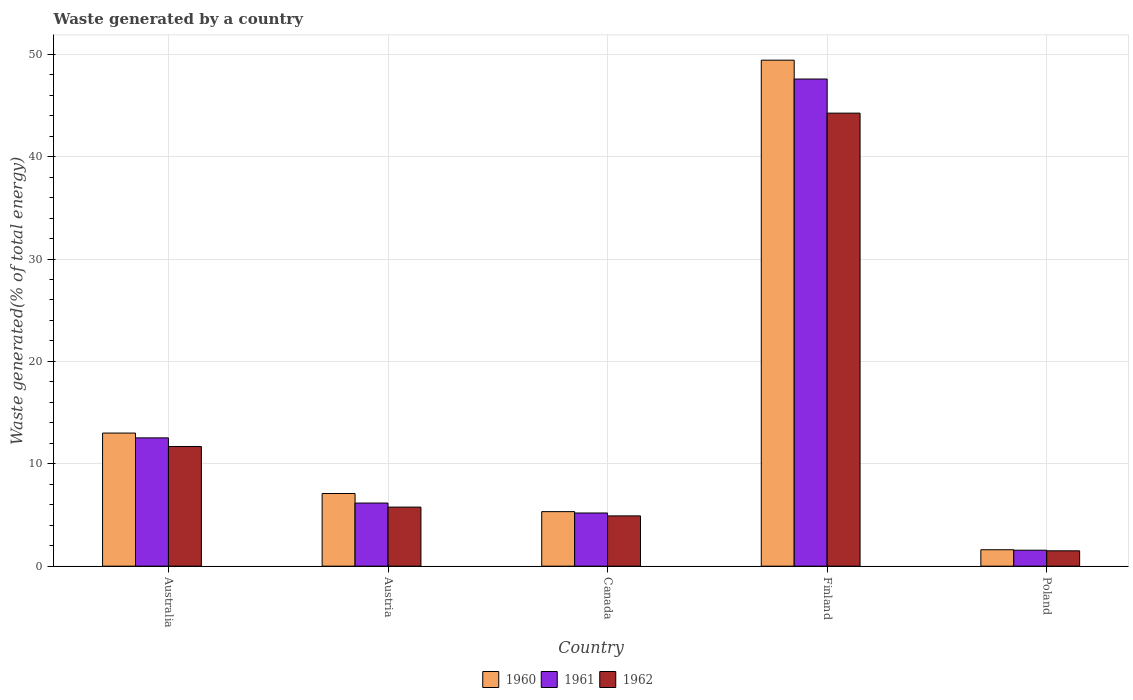How many different coloured bars are there?
Your answer should be very brief. 3. How many groups of bars are there?
Offer a terse response. 5. How many bars are there on the 1st tick from the left?
Your answer should be very brief. 3. In how many cases, is the number of bars for a given country not equal to the number of legend labels?
Offer a terse response. 0. What is the total waste generated in 1962 in Australia?
Give a very brief answer. 11.69. Across all countries, what is the maximum total waste generated in 1960?
Ensure brevity in your answer.  49.42. Across all countries, what is the minimum total waste generated in 1961?
Provide a succinct answer. 1.56. What is the total total waste generated in 1960 in the graph?
Offer a very short reply. 76.45. What is the difference between the total waste generated in 1960 in Canada and that in Poland?
Your response must be concise. 3.72. What is the difference between the total waste generated in 1961 in Australia and the total waste generated in 1960 in Finland?
Your answer should be very brief. -36.89. What is the average total waste generated in 1960 per country?
Offer a terse response. 15.29. What is the difference between the total waste generated of/in 1962 and total waste generated of/in 1960 in Canada?
Offer a terse response. -0.42. In how many countries, is the total waste generated in 1962 greater than 38 %?
Give a very brief answer. 1. What is the ratio of the total waste generated in 1960 in Australia to that in Canada?
Keep it short and to the point. 2.44. What is the difference between the highest and the second highest total waste generated in 1960?
Offer a very short reply. 36.42. What is the difference between the highest and the lowest total waste generated in 1962?
Provide a short and direct response. 42.75. In how many countries, is the total waste generated in 1962 greater than the average total waste generated in 1962 taken over all countries?
Provide a short and direct response. 1. What does the 3rd bar from the left in Australia represents?
Your answer should be compact. 1962. Is it the case that in every country, the sum of the total waste generated in 1962 and total waste generated in 1961 is greater than the total waste generated in 1960?
Keep it short and to the point. Yes. How many bars are there?
Offer a terse response. 15. What is the difference between two consecutive major ticks on the Y-axis?
Make the answer very short. 10. Does the graph contain any zero values?
Provide a succinct answer. No. Does the graph contain grids?
Ensure brevity in your answer.  Yes. Where does the legend appear in the graph?
Offer a very short reply. Bottom center. What is the title of the graph?
Your response must be concise. Waste generated by a country. What is the label or title of the X-axis?
Provide a succinct answer. Country. What is the label or title of the Y-axis?
Provide a short and direct response. Waste generated(% of total energy). What is the Waste generated(% of total energy) of 1960 in Australia?
Make the answer very short. 13. What is the Waste generated(% of total energy) of 1961 in Australia?
Your answer should be compact. 12.53. What is the Waste generated(% of total energy) in 1962 in Australia?
Offer a very short reply. 11.69. What is the Waste generated(% of total energy) of 1960 in Austria?
Give a very brief answer. 7.1. What is the Waste generated(% of total energy) of 1961 in Austria?
Keep it short and to the point. 6.16. What is the Waste generated(% of total energy) of 1962 in Austria?
Ensure brevity in your answer.  5.77. What is the Waste generated(% of total energy) in 1960 in Canada?
Provide a short and direct response. 5.33. What is the Waste generated(% of total energy) in 1961 in Canada?
Provide a succinct answer. 5.19. What is the Waste generated(% of total energy) in 1962 in Canada?
Provide a succinct answer. 4.91. What is the Waste generated(% of total energy) of 1960 in Finland?
Offer a terse response. 49.42. What is the Waste generated(% of total energy) of 1961 in Finland?
Offer a terse response. 47.58. What is the Waste generated(% of total energy) in 1962 in Finland?
Provide a short and direct response. 44.25. What is the Waste generated(% of total energy) in 1960 in Poland?
Provide a succinct answer. 1.6. What is the Waste generated(% of total energy) of 1961 in Poland?
Your answer should be compact. 1.56. What is the Waste generated(% of total energy) in 1962 in Poland?
Ensure brevity in your answer.  1.5. Across all countries, what is the maximum Waste generated(% of total energy) of 1960?
Provide a short and direct response. 49.42. Across all countries, what is the maximum Waste generated(% of total energy) of 1961?
Ensure brevity in your answer.  47.58. Across all countries, what is the maximum Waste generated(% of total energy) in 1962?
Offer a very short reply. 44.25. Across all countries, what is the minimum Waste generated(% of total energy) of 1960?
Provide a short and direct response. 1.6. Across all countries, what is the minimum Waste generated(% of total energy) of 1961?
Provide a succinct answer. 1.56. Across all countries, what is the minimum Waste generated(% of total energy) in 1962?
Make the answer very short. 1.5. What is the total Waste generated(% of total energy) in 1960 in the graph?
Provide a succinct answer. 76.45. What is the total Waste generated(% of total energy) in 1961 in the graph?
Your answer should be compact. 73.03. What is the total Waste generated(% of total energy) of 1962 in the graph?
Provide a succinct answer. 68.12. What is the difference between the Waste generated(% of total energy) in 1960 in Australia and that in Austria?
Provide a succinct answer. 5.9. What is the difference between the Waste generated(% of total energy) in 1961 in Australia and that in Austria?
Ensure brevity in your answer.  6.37. What is the difference between the Waste generated(% of total energy) in 1962 in Australia and that in Austria?
Keep it short and to the point. 5.92. What is the difference between the Waste generated(% of total energy) in 1960 in Australia and that in Canada?
Provide a succinct answer. 7.67. What is the difference between the Waste generated(% of total energy) of 1961 in Australia and that in Canada?
Ensure brevity in your answer.  7.34. What is the difference between the Waste generated(% of total energy) of 1962 in Australia and that in Canada?
Give a very brief answer. 6.78. What is the difference between the Waste generated(% of total energy) of 1960 in Australia and that in Finland?
Your answer should be very brief. -36.42. What is the difference between the Waste generated(% of total energy) of 1961 in Australia and that in Finland?
Your answer should be very brief. -35.05. What is the difference between the Waste generated(% of total energy) of 1962 in Australia and that in Finland?
Keep it short and to the point. -32.56. What is the difference between the Waste generated(% of total energy) in 1960 in Australia and that in Poland?
Keep it short and to the point. 11.4. What is the difference between the Waste generated(% of total energy) in 1961 in Australia and that in Poland?
Offer a terse response. 10.97. What is the difference between the Waste generated(% of total energy) in 1962 in Australia and that in Poland?
Your response must be concise. 10.19. What is the difference between the Waste generated(% of total energy) in 1960 in Austria and that in Canada?
Offer a very short reply. 1.77. What is the difference between the Waste generated(% of total energy) of 1961 in Austria and that in Canada?
Offer a very short reply. 0.97. What is the difference between the Waste generated(% of total energy) of 1962 in Austria and that in Canada?
Offer a very short reply. 0.86. What is the difference between the Waste generated(% of total energy) in 1960 in Austria and that in Finland?
Offer a terse response. -42.33. What is the difference between the Waste generated(% of total energy) in 1961 in Austria and that in Finland?
Give a very brief answer. -41.42. What is the difference between the Waste generated(% of total energy) in 1962 in Austria and that in Finland?
Your response must be concise. -38.48. What is the difference between the Waste generated(% of total energy) of 1960 in Austria and that in Poland?
Give a very brief answer. 5.49. What is the difference between the Waste generated(% of total energy) in 1961 in Austria and that in Poland?
Your answer should be very brief. 4.61. What is the difference between the Waste generated(% of total energy) in 1962 in Austria and that in Poland?
Ensure brevity in your answer.  4.27. What is the difference between the Waste generated(% of total energy) in 1960 in Canada and that in Finland?
Provide a succinct answer. -44.1. What is the difference between the Waste generated(% of total energy) of 1961 in Canada and that in Finland?
Offer a terse response. -42.39. What is the difference between the Waste generated(% of total energy) in 1962 in Canada and that in Finland?
Your response must be concise. -39.34. What is the difference between the Waste generated(% of total energy) in 1960 in Canada and that in Poland?
Your answer should be very brief. 3.72. What is the difference between the Waste generated(% of total energy) of 1961 in Canada and that in Poland?
Ensure brevity in your answer.  3.64. What is the difference between the Waste generated(% of total energy) of 1962 in Canada and that in Poland?
Offer a very short reply. 3.41. What is the difference between the Waste generated(% of total energy) in 1960 in Finland and that in Poland?
Provide a short and direct response. 47.82. What is the difference between the Waste generated(% of total energy) in 1961 in Finland and that in Poland?
Make the answer very short. 46.02. What is the difference between the Waste generated(% of total energy) of 1962 in Finland and that in Poland?
Offer a terse response. 42.75. What is the difference between the Waste generated(% of total energy) of 1960 in Australia and the Waste generated(% of total energy) of 1961 in Austria?
Give a very brief answer. 6.84. What is the difference between the Waste generated(% of total energy) in 1960 in Australia and the Waste generated(% of total energy) in 1962 in Austria?
Make the answer very short. 7.23. What is the difference between the Waste generated(% of total energy) of 1961 in Australia and the Waste generated(% of total energy) of 1962 in Austria?
Give a very brief answer. 6.76. What is the difference between the Waste generated(% of total energy) in 1960 in Australia and the Waste generated(% of total energy) in 1961 in Canada?
Keep it short and to the point. 7.81. What is the difference between the Waste generated(% of total energy) in 1960 in Australia and the Waste generated(% of total energy) in 1962 in Canada?
Provide a short and direct response. 8.09. What is the difference between the Waste generated(% of total energy) of 1961 in Australia and the Waste generated(% of total energy) of 1962 in Canada?
Your answer should be compact. 7.62. What is the difference between the Waste generated(% of total energy) in 1960 in Australia and the Waste generated(% of total energy) in 1961 in Finland?
Provide a succinct answer. -34.58. What is the difference between the Waste generated(% of total energy) of 1960 in Australia and the Waste generated(% of total energy) of 1962 in Finland?
Ensure brevity in your answer.  -31.25. What is the difference between the Waste generated(% of total energy) of 1961 in Australia and the Waste generated(% of total energy) of 1962 in Finland?
Ensure brevity in your answer.  -31.72. What is the difference between the Waste generated(% of total energy) of 1960 in Australia and the Waste generated(% of total energy) of 1961 in Poland?
Your answer should be very brief. 11.44. What is the difference between the Waste generated(% of total energy) in 1960 in Australia and the Waste generated(% of total energy) in 1962 in Poland?
Provide a short and direct response. 11.5. What is the difference between the Waste generated(% of total energy) in 1961 in Australia and the Waste generated(% of total energy) in 1962 in Poland?
Keep it short and to the point. 11.03. What is the difference between the Waste generated(% of total energy) in 1960 in Austria and the Waste generated(% of total energy) in 1961 in Canada?
Keep it short and to the point. 1.9. What is the difference between the Waste generated(% of total energy) of 1960 in Austria and the Waste generated(% of total energy) of 1962 in Canada?
Give a very brief answer. 2.19. What is the difference between the Waste generated(% of total energy) in 1961 in Austria and the Waste generated(% of total energy) in 1962 in Canada?
Offer a terse response. 1.25. What is the difference between the Waste generated(% of total energy) in 1960 in Austria and the Waste generated(% of total energy) in 1961 in Finland?
Your answer should be very brief. -40.48. What is the difference between the Waste generated(% of total energy) of 1960 in Austria and the Waste generated(% of total energy) of 1962 in Finland?
Offer a terse response. -37.15. What is the difference between the Waste generated(% of total energy) in 1961 in Austria and the Waste generated(% of total energy) in 1962 in Finland?
Your answer should be very brief. -38.09. What is the difference between the Waste generated(% of total energy) of 1960 in Austria and the Waste generated(% of total energy) of 1961 in Poland?
Your answer should be compact. 5.54. What is the difference between the Waste generated(% of total energy) in 1960 in Austria and the Waste generated(% of total energy) in 1962 in Poland?
Offer a terse response. 5.6. What is the difference between the Waste generated(% of total energy) of 1961 in Austria and the Waste generated(% of total energy) of 1962 in Poland?
Your answer should be compact. 4.67. What is the difference between the Waste generated(% of total energy) of 1960 in Canada and the Waste generated(% of total energy) of 1961 in Finland?
Give a very brief answer. -42.25. What is the difference between the Waste generated(% of total energy) of 1960 in Canada and the Waste generated(% of total energy) of 1962 in Finland?
Keep it short and to the point. -38.92. What is the difference between the Waste generated(% of total energy) in 1961 in Canada and the Waste generated(% of total energy) in 1962 in Finland?
Ensure brevity in your answer.  -39.06. What is the difference between the Waste generated(% of total energy) in 1960 in Canada and the Waste generated(% of total energy) in 1961 in Poland?
Give a very brief answer. 3.77. What is the difference between the Waste generated(% of total energy) of 1960 in Canada and the Waste generated(% of total energy) of 1962 in Poland?
Ensure brevity in your answer.  3.83. What is the difference between the Waste generated(% of total energy) in 1961 in Canada and the Waste generated(% of total energy) in 1962 in Poland?
Your response must be concise. 3.7. What is the difference between the Waste generated(% of total energy) of 1960 in Finland and the Waste generated(% of total energy) of 1961 in Poland?
Offer a terse response. 47.86. What is the difference between the Waste generated(% of total energy) of 1960 in Finland and the Waste generated(% of total energy) of 1962 in Poland?
Your answer should be compact. 47.92. What is the difference between the Waste generated(% of total energy) of 1961 in Finland and the Waste generated(% of total energy) of 1962 in Poland?
Offer a terse response. 46.08. What is the average Waste generated(% of total energy) of 1960 per country?
Ensure brevity in your answer.  15.29. What is the average Waste generated(% of total energy) of 1961 per country?
Give a very brief answer. 14.61. What is the average Waste generated(% of total energy) in 1962 per country?
Your response must be concise. 13.62. What is the difference between the Waste generated(% of total energy) of 1960 and Waste generated(% of total energy) of 1961 in Australia?
Your response must be concise. 0.47. What is the difference between the Waste generated(% of total energy) in 1960 and Waste generated(% of total energy) in 1962 in Australia?
Keep it short and to the point. 1.31. What is the difference between the Waste generated(% of total energy) of 1961 and Waste generated(% of total energy) of 1962 in Australia?
Your answer should be very brief. 0.84. What is the difference between the Waste generated(% of total energy) in 1960 and Waste generated(% of total energy) in 1961 in Austria?
Offer a very short reply. 0.93. What is the difference between the Waste generated(% of total energy) of 1960 and Waste generated(% of total energy) of 1962 in Austria?
Give a very brief answer. 1.33. What is the difference between the Waste generated(% of total energy) in 1961 and Waste generated(% of total energy) in 1962 in Austria?
Your answer should be compact. 0.4. What is the difference between the Waste generated(% of total energy) in 1960 and Waste generated(% of total energy) in 1961 in Canada?
Offer a terse response. 0.13. What is the difference between the Waste generated(% of total energy) of 1960 and Waste generated(% of total energy) of 1962 in Canada?
Give a very brief answer. 0.42. What is the difference between the Waste generated(% of total energy) in 1961 and Waste generated(% of total energy) in 1962 in Canada?
Your answer should be very brief. 0.28. What is the difference between the Waste generated(% of total energy) in 1960 and Waste generated(% of total energy) in 1961 in Finland?
Offer a very short reply. 1.84. What is the difference between the Waste generated(% of total energy) of 1960 and Waste generated(% of total energy) of 1962 in Finland?
Make the answer very short. 5.17. What is the difference between the Waste generated(% of total energy) in 1961 and Waste generated(% of total energy) in 1962 in Finland?
Your response must be concise. 3.33. What is the difference between the Waste generated(% of total energy) of 1960 and Waste generated(% of total energy) of 1961 in Poland?
Provide a succinct answer. 0.05. What is the difference between the Waste generated(% of total energy) in 1960 and Waste generated(% of total energy) in 1962 in Poland?
Your response must be concise. 0.11. What is the difference between the Waste generated(% of total energy) in 1961 and Waste generated(% of total energy) in 1962 in Poland?
Provide a succinct answer. 0.06. What is the ratio of the Waste generated(% of total energy) in 1960 in Australia to that in Austria?
Offer a terse response. 1.83. What is the ratio of the Waste generated(% of total energy) of 1961 in Australia to that in Austria?
Offer a terse response. 2.03. What is the ratio of the Waste generated(% of total energy) in 1962 in Australia to that in Austria?
Your answer should be very brief. 2.03. What is the ratio of the Waste generated(% of total energy) of 1960 in Australia to that in Canada?
Offer a very short reply. 2.44. What is the ratio of the Waste generated(% of total energy) of 1961 in Australia to that in Canada?
Offer a terse response. 2.41. What is the ratio of the Waste generated(% of total energy) of 1962 in Australia to that in Canada?
Offer a very short reply. 2.38. What is the ratio of the Waste generated(% of total energy) in 1960 in Australia to that in Finland?
Offer a terse response. 0.26. What is the ratio of the Waste generated(% of total energy) of 1961 in Australia to that in Finland?
Ensure brevity in your answer.  0.26. What is the ratio of the Waste generated(% of total energy) in 1962 in Australia to that in Finland?
Provide a succinct answer. 0.26. What is the ratio of the Waste generated(% of total energy) in 1960 in Australia to that in Poland?
Your answer should be compact. 8.1. What is the ratio of the Waste generated(% of total energy) in 1961 in Australia to that in Poland?
Provide a short and direct response. 8.04. What is the ratio of the Waste generated(% of total energy) in 1962 in Australia to that in Poland?
Your answer should be very brief. 7.8. What is the ratio of the Waste generated(% of total energy) of 1960 in Austria to that in Canada?
Your response must be concise. 1.33. What is the ratio of the Waste generated(% of total energy) of 1961 in Austria to that in Canada?
Your answer should be very brief. 1.19. What is the ratio of the Waste generated(% of total energy) of 1962 in Austria to that in Canada?
Provide a succinct answer. 1.17. What is the ratio of the Waste generated(% of total energy) in 1960 in Austria to that in Finland?
Keep it short and to the point. 0.14. What is the ratio of the Waste generated(% of total energy) in 1961 in Austria to that in Finland?
Offer a very short reply. 0.13. What is the ratio of the Waste generated(% of total energy) in 1962 in Austria to that in Finland?
Your answer should be compact. 0.13. What is the ratio of the Waste generated(% of total energy) in 1960 in Austria to that in Poland?
Make the answer very short. 4.42. What is the ratio of the Waste generated(% of total energy) of 1961 in Austria to that in Poland?
Provide a short and direct response. 3.96. What is the ratio of the Waste generated(% of total energy) of 1962 in Austria to that in Poland?
Keep it short and to the point. 3.85. What is the ratio of the Waste generated(% of total energy) in 1960 in Canada to that in Finland?
Keep it short and to the point. 0.11. What is the ratio of the Waste generated(% of total energy) in 1961 in Canada to that in Finland?
Offer a terse response. 0.11. What is the ratio of the Waste generated(% of total energy) in 1962 in Canada to that in Finland?
Make the answer very short. 0.11. What is the ratio of the Waste generated(% of total energy) of 1960 in Canada to that in Poland?
Provide a short and direct response. 3.32. What is the ratio of the Waste generated(% of total energy) in 1961 in Canada to that in Poland?
Provide a short and direct response. 3.33. What is the ratio of the Waste generated(% of total energy) in 1962 in Canada to that in Poland?
Offer a terse response. 3.28. What is the ratio of the Waste generated(% of total energy) in 1960 in Finland to that in Poland?
Provide a succinct answer. 30.8. What is the ratio of the Waste generated(% of total energy) in 1961 in Finland to that in Poland?
Your response must be concise. 30.53. What is the ratio of the Waste generated(% of total energy) of 1962 in Finland to that in Poland?
Offer a very short reply. 29.52. What is the difference between the highest and the second highest Waste generated(% of total energy) in 1960?
Provide a succinct answer. 36.42. What is the difference between the highest and the second highest Waste generated(% of total energy) of 1961?
Make the answer very short. 35.05. What is the difference between the highest and the second highest Waste generated(% of total energy) of 1962?
Your answer should be very brief. 32.56. What is the difference between the highest and the lowest Waste generated(% of total energy) of 1960?
Ensure brevity in your answer.  47.82. What is the difference between the highest and the lowest Waste generated(% of total energy) of 1961?
Ensure brevity in your answer.  46.02. What is the difference between the highest and the lowest Waste generated(% of total energy) of 1962?
Offer a terse response. 42.75. 